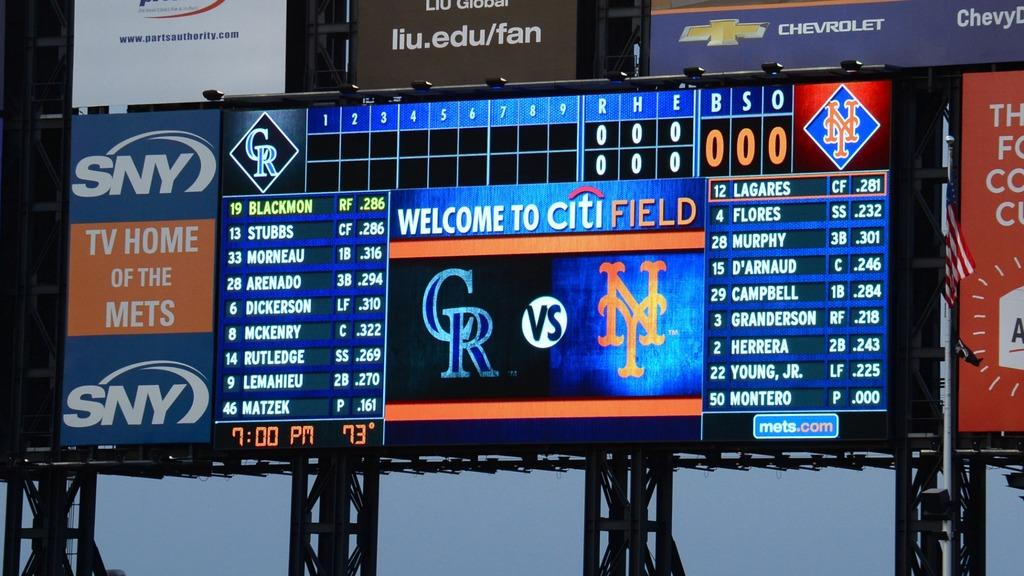<image>
Provide a brief description of the given image. Citi Field is home to the Mets and the scoreboard shows they are playing the Colorado Rockies. 